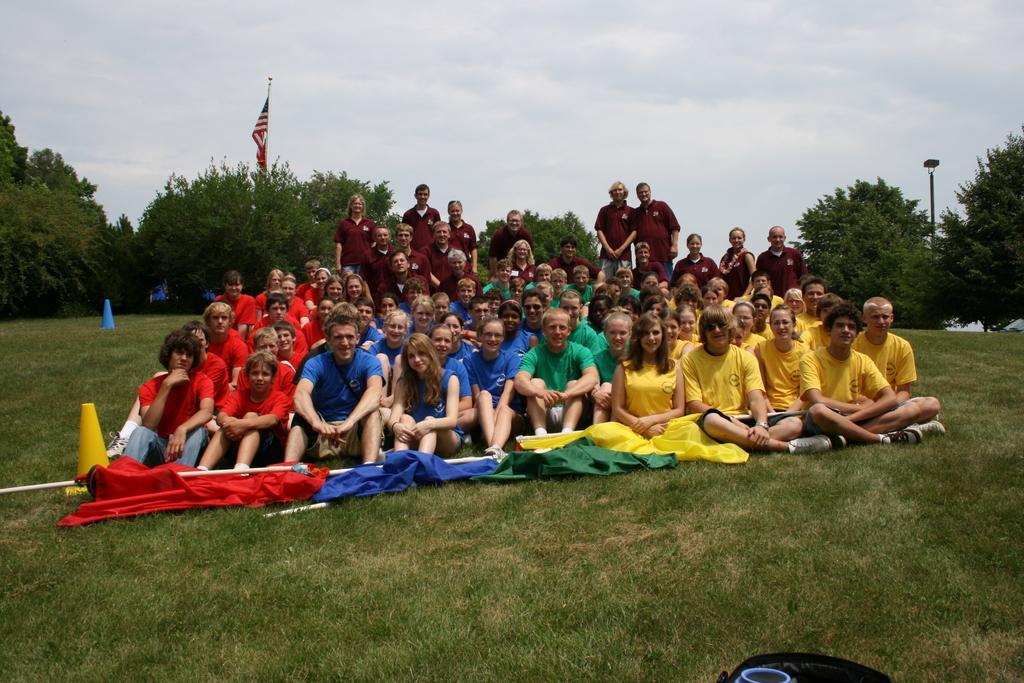Describe this image in one or two sentences. In this image I can see group of people. Also there are trees, poles, grass, flag and cone bar barricade. Also at the bottom of the image there is an object. 